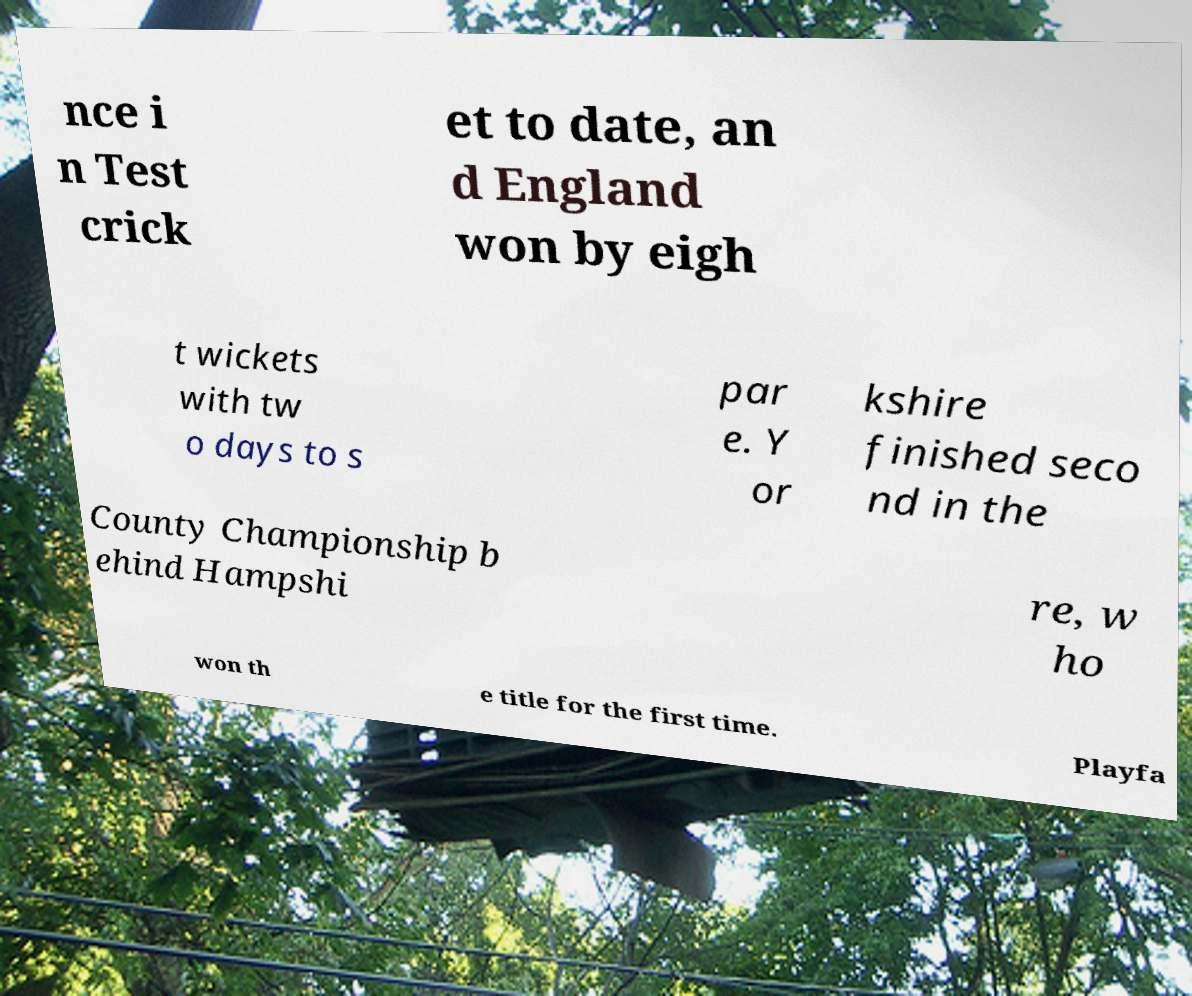What messages or text are displayed in this image? I need them in a readable, typed format. nce i n Test crick et to date, an d England won by eigh t wickets with tw o days to s par e. Y or kshire finished seco nd in the County Championship b ehind Hampshi re, w ho won th e title for the first time. Playfa 